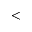<formula> <loc_0><loc_0><loc_500><loc_500><</formula> 